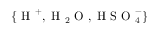<formula> <loc_0><loc_0><loc_500><loc_500>\{ H ^ { + } , H _ { 2 } O , H S O _ { 4 } ^ { - } \}</formula> 